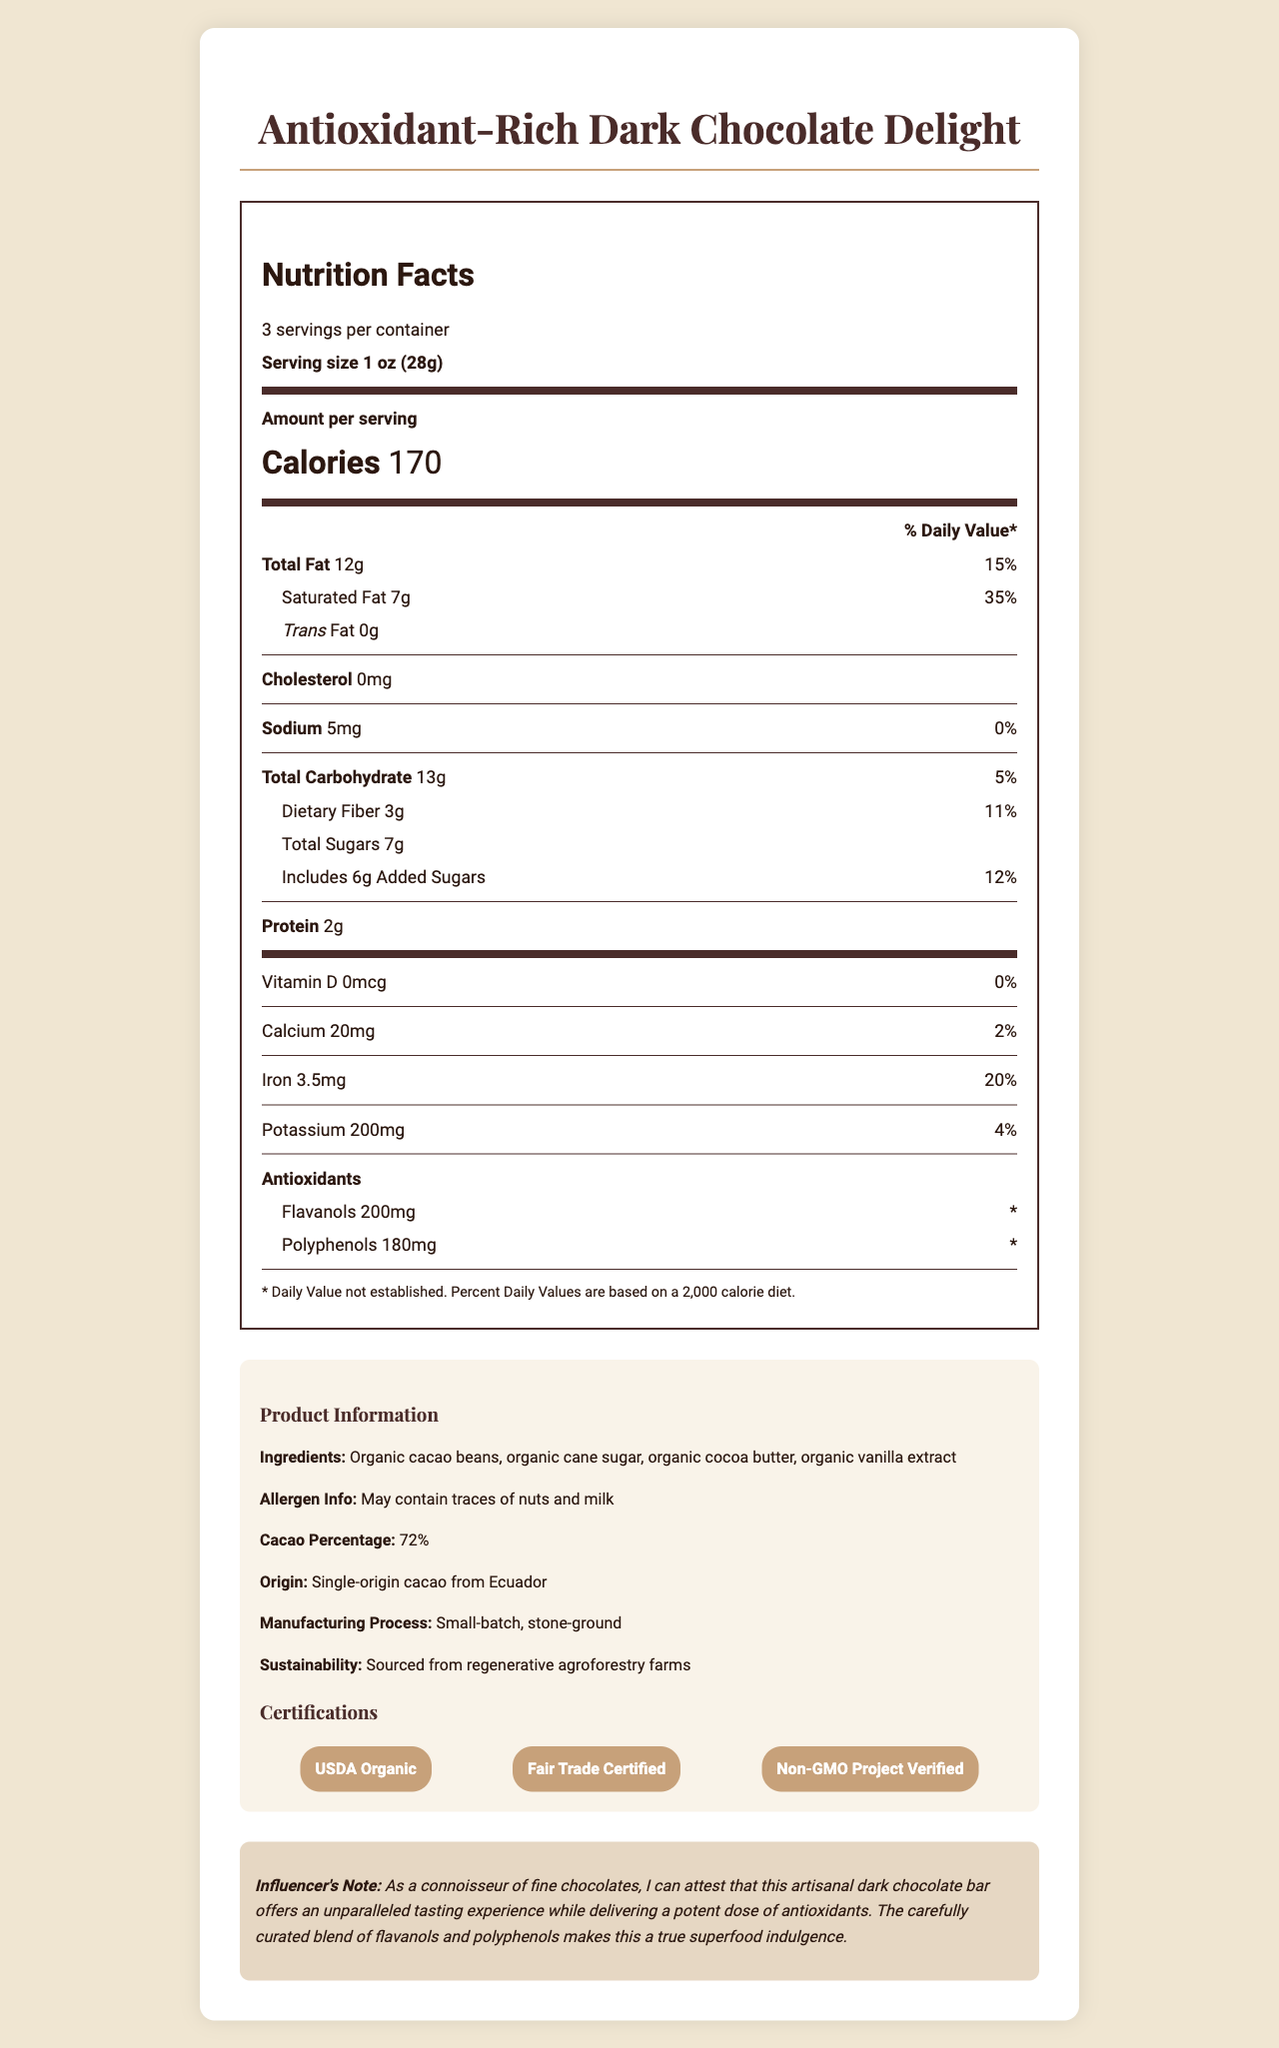What is the serving size of the Antioxidant-Rich Dark Chocolate Delight? The document specifies the serving size as 1 oz (28g).
Answer: 1 oz (28g) How many servings are there per container of this dark chocolate bar? The document states there are 3 servings per container.
Answer: 3 What is the percentage of the daily value for saturated fat per serving? In the nutrition label, it shows that the daily value percentage for saturated fat is 35%.
Answer: 35% How much iron does one serving contain, and what is its daily value percentage? The nutrition label indicates that one serving contains 3.5mg of iron, which is 20% of the daily value.
Answer: 3.5mg, 20% List two main types of antioxidants mentioned and their amounts per serving. In the nutrition facts label, under antioxidants, it lists 200mg of flavanols and 180mg of polyphenols per serving.
Answer: Flavanols: 200mg, Polyphenols: 180mg Which statement describes the sustainability of the product? A. Made with organic ingredients B. Sourced from regenerative agroforestry farms C. Non-GMO certified D. Fair Trade Certified The sustainability statement in the document mentions that the product is sourced from regenerative agroforestry farms.
Answer: B. Sourced from regenerative agroforestry farms What certifications does this dark chocolate bar have? A. USDA Organic B. Fair Trade Certified C. Non-GMO Project Verified D. All of the above The product has three certifications: USDA Organic, Fair Trade Certified, and Non-GMO Project Verified.
Answer: D. All of the above Does this chocolate contain any cholesterol? The document shows that the cholesterol amount is 0mg.
Answer: No Summarize the main idea of the document. The document provides a thorough breakdown of the nutrition facts such as calories, fats, carbohydrates, and proteins per serving. Additionally, it showcases the two main antioxidants present in the chocolate, the ingredients, potential allergens, certifications like USDA Organic, and a sourcing statement emphasizing sustainability.
Answer: This document details the nutrition facts and product information of the Antioxidant-Rich Dark Chocolate Delight, highlighting its serving size, calorie content, macronutrients, antioxidants, ingredients, certifications, and sustainable sourcing. Can you determine the retail price of this dark chocolate bar from the document? The document doesn't provide any information regarding the retail price of the dark chocolate bar.
Answer: Not enough information What is the total carbohydrate content per serving, and what percentage of the daily value does it represent? The nutrition label lists total carbohydrates as 13g, which represent 5% of the daily value.
Answer: 13g, 5% 